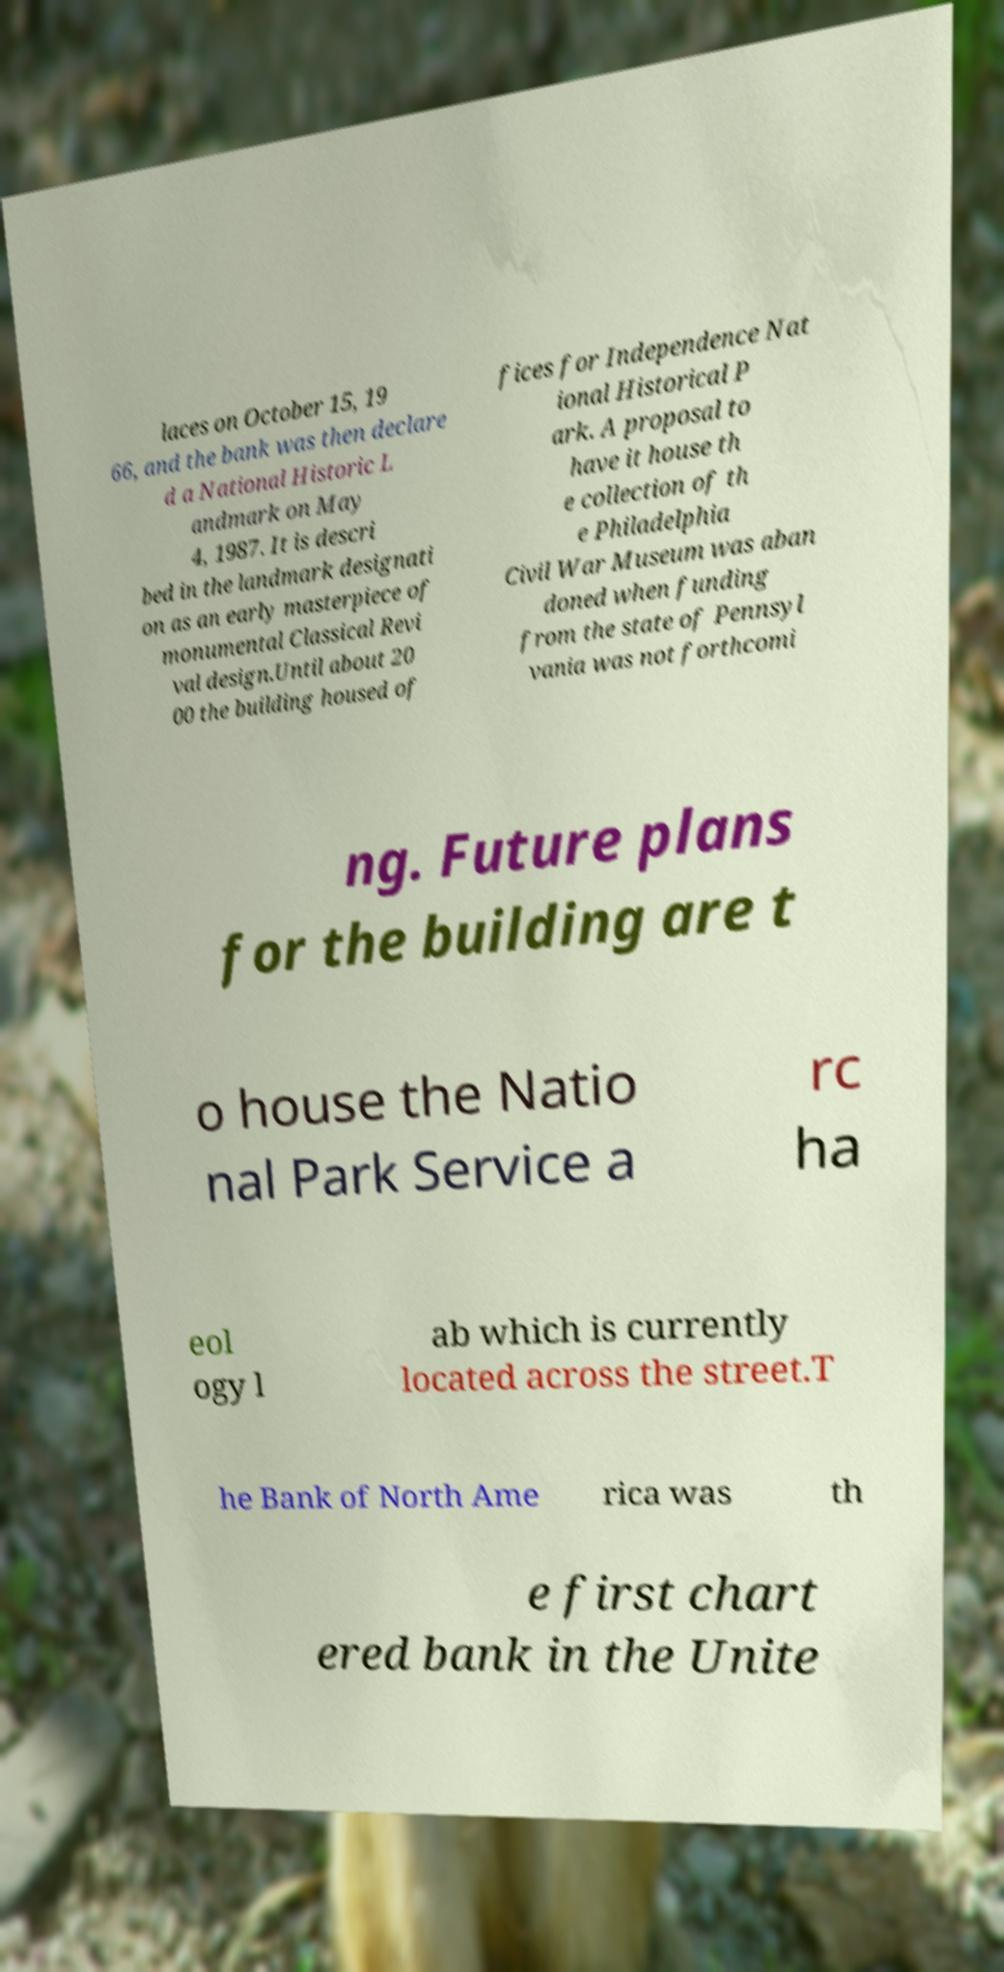For documentation purposes, I need the text within this image transcribed. Could you provide that? laces on October 15, 19 66, and the bank was then declare d a National Historic L andmark on May 4, 1987. It is descri bed in the landmark designati on as an early masterpiece of monumental Classical Revi val design.Until about 20 00 the building housed of fices for Independence Nat ional Historical P ark. A proposal to have it house th e collection of th e Philadelphia Civil War Museum was aban doned when funding from the state of Pennsyl vania was not forthcomi ng. Future plans for the building are t o house the Natio nal Park Service a rc ha eol ogy l ab which is currently located across the street.T he Bank of North Ame rica was th e first chart ered bank in the Unite 